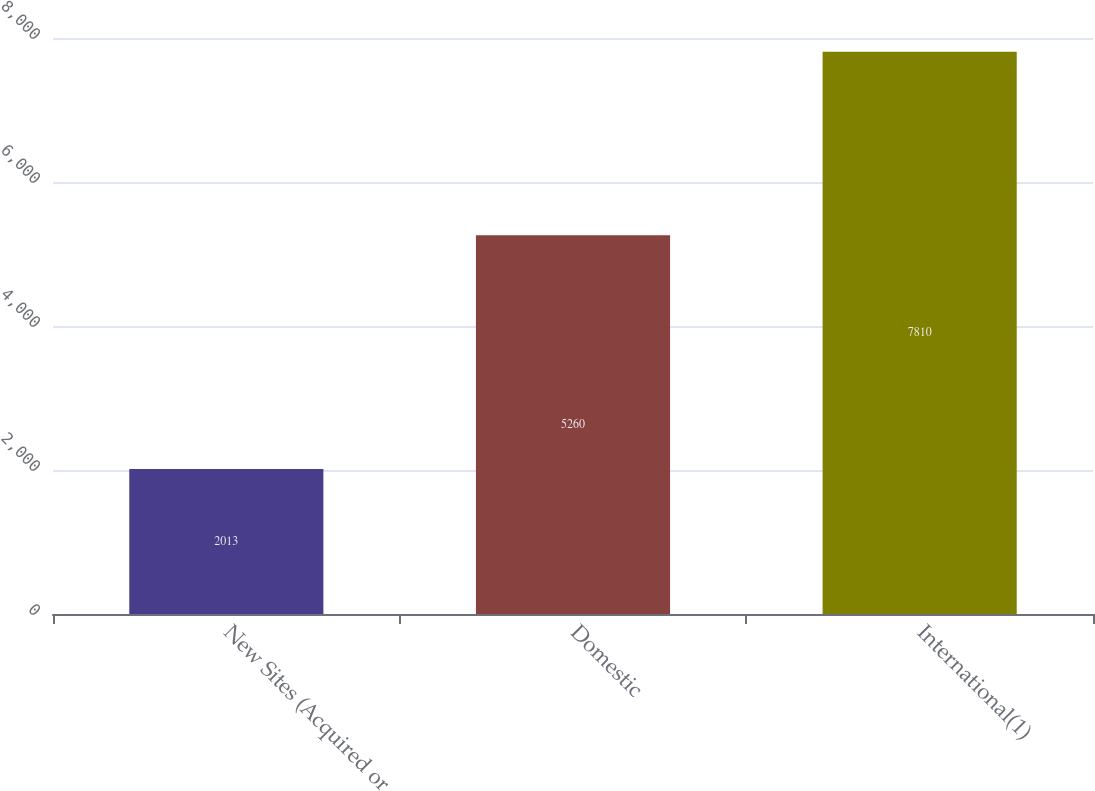Convert chart to OTSL. <chart><loc_0><loc_0><loc_500><loc_500><bar_chart><fcel>New Sites (Acquired or<fcel>Domestic<fcel>International(1)<nl><fcel>2013<fcel>5260<fcel>7810<nl></chart> 